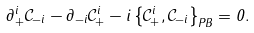Convert formula to latex. <formula><loc_0><loc_0><loc_500><loc_500>\partial _ { + } ^ { i } \mathcal { C } _ { - i } - \partial _ { - i } \mathcal { C } _ { + } ^ { i } - i \left \{ \mathcal { C } _ { + } ^ { i } , \mathcal { C } _ { - i } \right \} _ { P B } = 0 .</formula> 